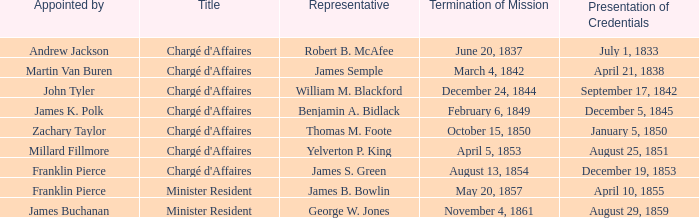What's the Representative listed that has a Presentation of Credentials of August 25, 1851? Yelverton P. King. 